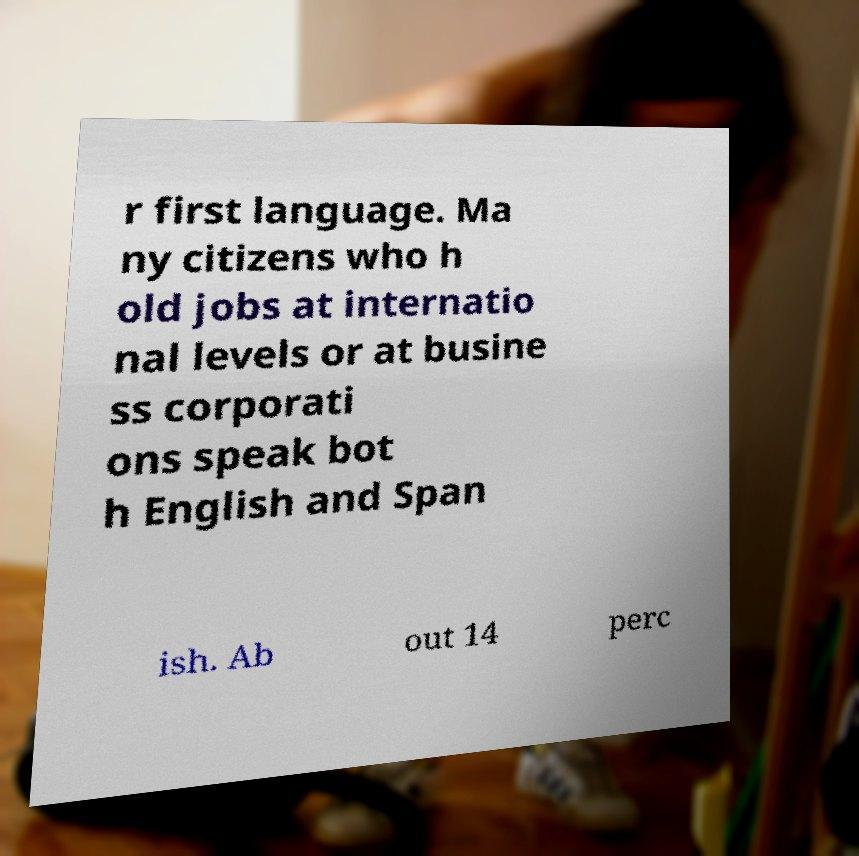Please identify and transcribe the text found in this image. r first language. Ma ny citizens who h old jobs at internatio nal levels or at busine ss corporati ons speak bot h English and Span ish. Ab out 14 perc 